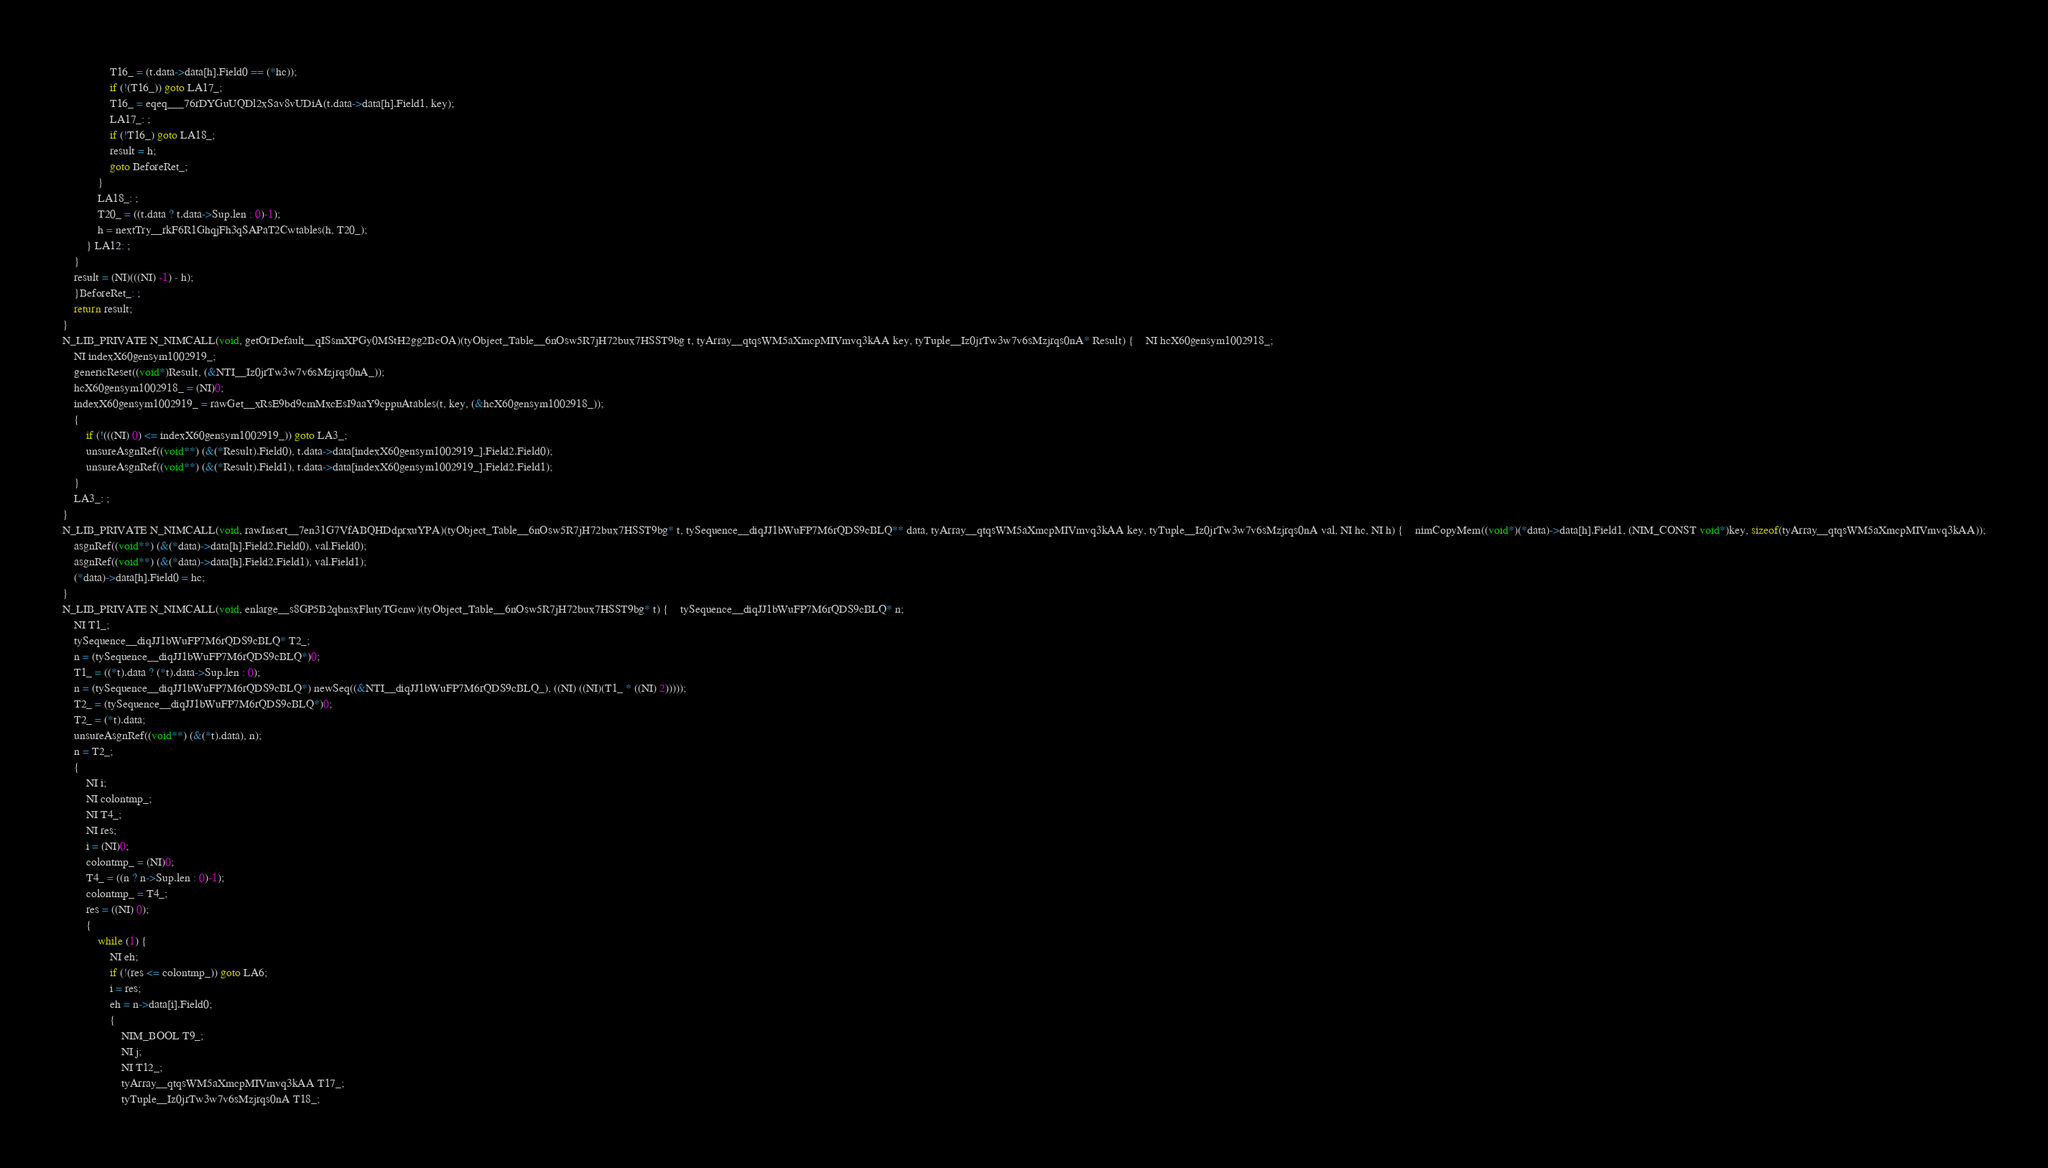<code> <loc_0><loc_0><loc_500><loc_500><_C_>				T16_ = (t.data->data[h].Field0 == (*hc));
				if (!(T16_)) goto LA17_;
				T16_ = eqeq___76rDYGuUQDl2xSav8vUDiA(t.data->data[h].Field1, key);
				LA17_: ;
				if (!T16_) goto LA18_;
				result = h;
				goto BeforeRet_;
			}
			LA18_: ;
			T20_ = ((t.data ? t.data->Sup.len : 0)-1);
			h = nextTry__rkF6R1GhqjFh3qSAPaT2Cwtables(h, T20_);
		} LA12: ;
	}
	result = (NI)(((NI) -1) - h);
	}BeforeRet_: ;
	return result;
}
N_LIB_PRIVATE N_NIMCALL(void, getOrDefault__qISsmXPGy0MStH2gg2BcOA)(tyObject_Table__6nOsw5R7jH72bux7HSST9bg t, tyArray__qtqsWM5aXmcpMIVmvq3kAA key, tyTuple__Iz0jrTw3w7v6sMzjrqs0nA* Result) {	NI hcX60gensym1002918_;
	NI indexX60gensym1002919_;
	genericReset((void*)Result, (&NTI__Iz0jrTw3w7v6sMzjrqs0nA_));
	hcX60gensym1002918_ = (NI)0;
	indexX60gensym1002919_ = rawGet__xRsE9bd9cmMxcEsI9aaY9cppuAtables(t, key, (&hcX60gensym1002918_));
	{
		if (!(((NI) 0) <= indexX60gensym1002919_)) goto LA3_;
		unsureAsgnRef((void**) (&(*Result).Field0), t.data->data[indexX60gensym1002919_].Field2.Field0);
		unsureAsgnRef((void**) (&(*Result).Field1), t.data->data[indexX60gensym1002919_].Field2.Field1);
	}
	LA3_: ;
}
N_LIB_PRIVATE N_NIMCALL(void, rawInsert__7en31G7VfABQHDdprxuYPA)(tyObject_Table__6nOsw5R7jH72bux7HSST9bg* t, tySequence__diqJJ1bWuFP7M6rQDS9cBLQ** data, tyArray__qtqsWM5aXmcpMIVmvq3kAA key, tyTuple__Iz0jrTw3w7v6sMzjrqs0nA val, NI hc, NI h) {	nimCopyMem((void*)(*data)->data[h].Field1, (NIM_CONST void*)key, sizeof(tyArray__qtqsWM5aXmcpMIVmvq3kAA));
	asgnRef((void**) (&(*data)->data[h].Field2.Field0), val.Field0);
	asgnRef((void**) (&(*data)->data[h].Field2.Field1), val.Field1);
	(*data)->data[h].Field0 = hc;
}
N_LIB_PRIVATE N_NIMCALL(void, enlarge__s8GP5B2qbnsxFlutyTGcnw)(tyObject_Table__6nOsw5R7jH72bux7HSST9bg* t) {	tySequence__diqJJ1bWuFP7M6rQDS9cBLQ* n;
	NI T1_;
	tySequence__diqJJ1bWuFP7M6rQDS9cBLQ* T2_;
	n = (tySequence__diqJJ1bWuFP7M6rQDS9cBLQ*)0;
	T1_ = ((*t).data ? (*t).data->Sup.len : 0);
	n = (tySequence__diqJJ1bWuFP7M6rQDS9cBLQ*) newSeq((&NTI__diqJJ1bWuFP7M6rQDS9cBLQ_), ((NI) ((NI)(T1_ * ((NI) 2)))));
	T2_ = (tySequence__diqJJ1bWuFP7M6rQDS9cBLQ*)0;
	T2_ = (*t).data;
	unsureAsgnRef((void**) (&(*t).data), n);
	n = T2_;
	{
		NI i;
		NI colontmp_;
		NI T4_;
		NI res;
		i = (NI)0;
		colontmp_ = (NI)0;
		T4_ = ((n ? n->Sup.len : 0)-1);
		colontmp_ = T4_;
		res = ((NI) 0);
		{
			while (1) {
				NI eh;
				if (!(res <= colontmp_)) goto LA6;
				i = res;
				eh = n->data[i].Field0;
				{
					NIM_BOOL T9_;
					NI j;
					NI T12_;
					tyArray__qtqsWM5aXmcpMIVmvq3kAA T17_;
					tyTuple__Iz0jrTw3w7v6sMzjrqs0nA T18_;</code> 